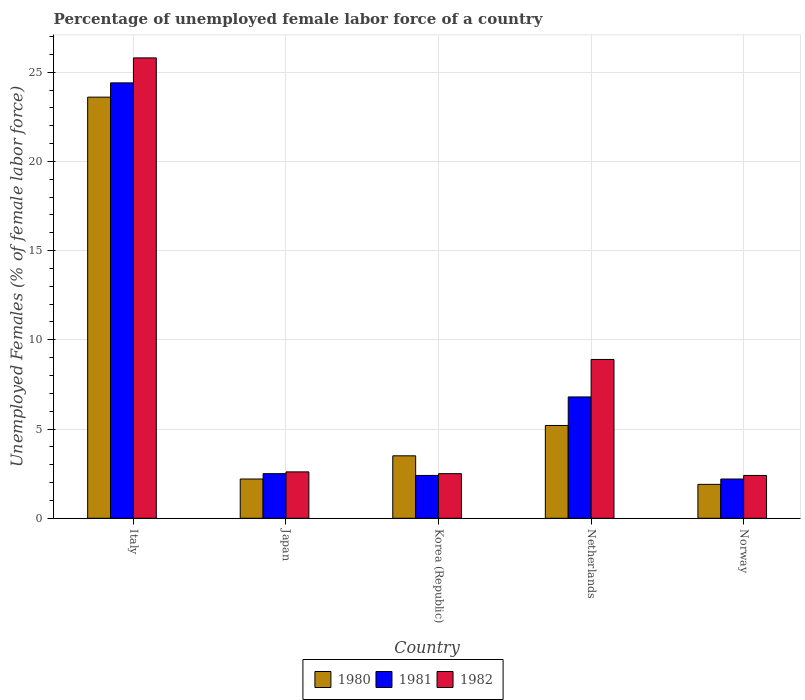Are the number of bars per tick equal to the number of legend labels?
Offer a terse response. Yes. What is the label of the 3rd group of bars from the left?
Keep it short and to the point. Korea (Republic). Across all countries, what is the maximum percentage of unemployed female labor force in 1981?
Keep it short and to the point. 24.4. Across all countries, what is the minimum percentage of unemployed female labor force in 1980?
Offer a terse response. 1.9. In which country was the percentage of unemployed female labor force in 1980 maximum?
Keep it short and to the point. Italy. In which country was the percentage of unemployed female labor force in 1980 minimum?
Ensure brevity in your answer.  Norway. What is the total percentage of unemployed female labor force in 1980 in the graph?
Make the answer very short. 36.4. What is the difference between the percentage of unemployed female labor force in 1981 in Netherlands and that in Norway?
Provide a short and direct response. 4.6. What is the difference between the percentage of unemployed female labor force in 1981 in Netherlands and the percentage of unemployed female labor force in 1980 in Norway?
Provide a short and direct response. 4.9. What is the average percentage of unemployed female labor force in 1980 per country?
Your answer should be very brief. 7.28. What is the difference between the percentage of unemployed female labor force of/in 1982 and percentage of unemployed female labor force of/in 1981 in Norway?
Your response must be concise. 0.2. What is the ratio of the percentage of unemployed female labor force in 1980 in Japan to that in Korea (Republic)?
Offer a very short reply. 0.63. What is the difference between the highest and the second highest percentage of unemployed female labor force in 1981?
Keep it short and to the point. 21.9. What is the difference between the highest and the lowest percentage of unemployed female labor force in 1980?
Offer a terse response. 21.7. What does the 2nd bar from the left in Japan represents?
Your answer should be very brief. 1981. What does the 2nd bar from the right in Italy represents?
Provide a short and direct response. 1981. How many bars are there?
Keep it short and to the point. 15. Are all the bars in the graph horizontal?
Your answer should be compact. No. Are the values on the major ticks of Y-axis written in scientific E-notation?
Your answer should be compact. No. Does the graph contain grids?
Give a very brief answer. Yes. How are the legend labels stacked?
Make the answer very short. Horizontal. What is the title of the graph?
Keep it short and to the point. Percentage of unemployed female labor force of a country. What is the label or title of the X-axis?
Your response must be concise. Country. What is the label or title of the Y-axis?
Provide a short and direct response. Unemployed Females (% of female labor force). What is the Unemployed Females (% of female labor force) in 1980 in Italy?
Provide a short and direct response. 23.6. What is the Unemployed Females (% of female labor force) in 1981 in Italy?
Your answer should be compact. 24.4. What is the Unemployed Females (% of female labor force) of 1982 in Italy?
Your answer should be compact. 25.8. What is the Unemployed Females (% of female labor force) in 1980 in Japan?
Provide a short and direct response. 2.2. What is the Unemployed Females (% of female labor force) of 1982 in Japan?
Give a very brief answer. 2.6. What is the Unemployed Females (% of female labor force) of 1980 in Korea (Republic)?
Make the answer very short. 3.5. What is the Unemployed Females (% of female labor force) in 1981 in Korea (Republic)?
Give a very brief answer. 2.4. What is the Unemployed Females (% of female labor force) of 1982 in Korea (Republic)?
Offer a very short reply. 2.5. What is the Unemployed Females (% of female labor force) of 1980 in Netherlands?
Ensure brevity in your answer.  5.2. What is the Unemployed Females (% of female labor force) in 1981 in Netherlands?
Give a very brief answer. 6.8. What is the Unemployed Females (% of female labor force) in 1982 in Netherlands?
Offer a very short reply. 8.9. What is the Unemployed Females (% of female labor force) of 1980 in Norway?
Provide a short and direct response. 1.9. What is the Unemployed Females (% of female labor force) in 1981 in Norway?
Offer a very short reply. 2.2. What is the Unemployed Females (% of female labor force) in 1982 in Norway?
Provide a succinct answer. 2.4. Across all countries, what is the maximum Unemployed Females (% of female labor force) in 1980?
Provide a succinct answer. 23.6. Across all countries, what is the maximum Unemployed Females (% of female labor force) of 1981?
Provide a short and direct response. 24.4. Across all countries, what is the maximum Unemployed Females (% of female labor force) in 1982?
Provide a short and direct response. 25.8. Across all countries, what is the minimum Unemployed Females (% of female labor force) of 1980?
Provide a short and direct response. 1.9. Across all countries, what is the minimum Unemployed Females (% of female labor force) of 1981?
Your answer should be very brief. 2.2. Across all countries, what is the minimum Unemployed Females (% of female labor force) in 1982?
Your response must be concise. 2.4. What is the total Unemployed Females (% of female labor force) of 1980 in the graph?
Your answer should be very brief. 36.4. What is the total Unemployed Females (% of female labor force) of 1981 in the graph?
Provide a succinct answer. 38.3. What is the total Unemployed Females (% of female labor force) in 1982 in the graph?
Your response must be concise. 42.2. What is the difference between the Unemployed Females (% of female labor force) of 1980 in Italy and that in Japan?
Your response must be concise. 21.4. What is the difference between the Unemployed Females (% of female labor force) of 1981 in Italy and that in Japan?
Keep it short and to the point. 21.9. What is the difference between the Unemployed Females (% of female labor force) in 1982 in Italy and that in Japan?
Provide a short and direct response. 23.2. What is the difference between the Unemployed Females (% of female labor force) in 1980 in Italy and that in Korea (Republic)?
Keep it short and to the point. 20.1. What is the difference between the Unemployed Females (% of female labor force) of 1981 in Italy and that in Korea (Republic)?
Give a very brief answer. 22. What is the difference between the Unemployed Females (% of female labor force) of 1982 in Italy and that in Korea (Republic)?
Offer a very short reply. 23.3. What is the difference between the Unemployed Females (% of female labor force) in 1980 in Italy and that in Norway?
Provide a succinct answer. 21.7. What is the difference between the Unemployed Females (% of female labor force) of 1982 in Italy and that in Norway?
Offer a very short reply. 23.4. What is the difference between the Unemployed Females (% of female labor force) in 1980 in Japan and that in Korea (Republic)?
Your answer should be very brief. -1.3. What is the difference between the Unemployed Females (% of female labor force) in 1981 in Japan and that in Korea (Republic)?
Provide a short and direct response. 0.1. What is the difference between the Unemployed Females (% of female labor force) of 1982 in Japan and that in Korea (Republic)?
Keep it short and to the point. 0.1. What is the difference between the Unemployed Females (% of female labor force) in 1980 in Japan and that in Netherlands?
Ensure brevity in your answer.  -3. What is the difference between the Unemployed Females (% of female labor force) in 1980 in Japan and that in Norway?
Give a very brief answer. 0.3. What is the difference between the Unemployed Females (% of female labor force) of 1981 in Japan and that in Norway?
Your answer should be compact. 0.3. What is the difference between the Unemployed Females (% of female labor force) of 1982 in Japan and that in Norway?
Offer a very short reply. 0.2. What is the difference between the Unemployed Females (% of female labor force) in 1981 in Korea (Republic) and that in Netherlands?
Provide a short and direct response. -4.4. What is the difference between the Unemployed Females (% of female labor force) of 1982 in Korea (Republic) and that in Netherlands?
Provide a succinct answer. -6.4. What is the difference between the Unemployed Females (% of female labor force) in 1982 in Korea (Republic) and that in Norway?
Your answer should be very brief. 0.1. What is the difference between the Unemployed Females (% of female labor force) of 1980 in Netherlands and that in Norway?
Offer a terse response. 3.3. What is the difference between the Unemployed Females (% of female labor force) of 1981 in Netherlands and that in Norway?
Offer a terse response. 4.6. What is the difference between the Unemployed Females (% of female labor force) of 1980 in Italy and the Unemployed Females (% of female labor force) of 1981 in Japan?
Ensure brevity in your answer.  21.1. What is the difference between the Unemployed Females (% of female labor force) of 1980 in Italy and the Unemployed Females (% of female labor force) of 1982 in Japan?
Ensure brevity in your answer.  21. What is the difference between the Unemployed Females (% of female labor force) of 1981 in Italy and the Unemployed Females (% of female labor force) of 1982 in Japan?
Provide a short and direct response. 21.8. What is the difference between the Unemployed Females (% of female labor force) in 1980 in Italy and the Unemployed Females (% of female labor force) in 1981 in Korea (Republic)?
Your response must be concise. 21.2. What is the difference between the Unemployed Females (% of female labor force) in 1980 in Italy and the Unemployed Females (% of female labor force) in 1982 in Korea (Republic)?
Your answer should be very brief. 21.1. What is the difference between the Unemployed Females (% of female labor force) in 1981 in Italy and the Unemployed Females (% of female labor force) in 1982 in Korea (Republic)?
Offer a terse response. 21.9. What is the difference between the Unemployed Females (% of female labor force) of 1980 in Italy and the Unemployed Females (% of female labor force) of 1981 in Netherlands?
Your response must be concise. 16.8. What is the difference between the Unemployed Females (% of female labor force) in 1980 in Italy and the Unemployed Females (% of female labor force) in 1982 in Netherlands?
Offer a very short reply. 14.7. What is the difference between the Unemployed Females (% of female labor force) in 1980 in Italy and the Unemployed Females (% of female labor force) in 1981 in Norway?
Your answer should be very brief. 21.4. What is the difference between the Unemployed Females (% of female labor force) in 1980 in Italy and the Unemployed Females (% of female labor force) in 1982 in Norway?
Provide a succinct answer. 21.2. What is the difference between the Unemployed Females (% of female labor force) in 1981 in Italy and the Unemployed Females (% of female labor force) in 1982 in Norway?
Provide a short and direct response. 22. What is the difference between the Unemployed Females (% of female labor force) in 1980 in Japan and the Unemployed Females (% of female labor force) in 1982 in Korea (Republic)?
Provide a succinct answer. -0.3. What is the difference between the Unemployed Females (% of female labor force) of 1981 in Japan and the Unemployed Females (% of female labor force) of 1982 in Korea (Republic)?
Your answer should be compact. 0. What is the difference between the Unemployed Females (% of female labor force) in 1980 in Japan and the Unemployed Females (% of female labor force) in 1982 in Norway?
Keep it short and to the point. -0.2. What is the difference between the Unemployed Females (% of female labor force) of 1981 in Japan and the Unemployed Females (% of female labor force) of 1982 in Norway?
Ensure brevity in your answer.  0.1. What is the difference between the Unemployed Females (% of female labor force) of 1981 in Korea (Republic) and the Unemployed Females (% of female labor force) of 1982 in Norway?
Your response must be concise. 0. What is the difference between the Unemployed Females (% of female labor force) of 1980 in Netherlands and the Unemployed Females (% of female labor force) of 1981 in Norway?
Offer a very short reply. 3. What is the average Unemployed Females (% of female labor force) of 1980 per country?
Your answer should be very brief. 7.28. What is the average Unemployed Females (% of female labor force) of 1981 per country?
Provide a short and direct response. 7.66. What is the average Unemployed Females (% of female labor force) in 1982 per country?
Your answer should be compact. 8.44. What is the difference between the Unemployed Females (% of female labor force) of 1980 and Unemployed Females (% of female labor force) of 1982 in Italy?
Your answer should be very brief. -2.2. What is the difference between the Unemployed Females (% of female labor force) in 1981 and Unemployed Females (% of female labor force) in 1982 in Italy?
Your response must be concise. -1.4. What is the difference between the Unemployed Females (% of female labor force) in 1980 and Unemployed Females (% of female labor force) in 1982 in Japan?
Provide a short and direct response. -0.4. What is the difference between the Unemployed Females (% of female labor force) of 1981 and Unemployed Females (% of female labor force) of 1982 in Japan?
Keep it short and to the point. -0.1. What is the difference between the Unemployed Females (% of female labor force) of 1980 and Unemployed Females (% of female labor force) of 1981 in Korea (Republic)?
Offer a terse response. 1.1. What is the difference between the Unemployed Females (% of female labor force) in 1980 and Unemployed Females (% of female labor force) in 1982 in Korea (Republic)?
Ensure brevity in your answer.  1. What is the difference between the Unemployed Females (% of female labor force) in 1981 and Unemployed Females (% of female labor force) in 1982 in Korea (Republic)?
Your response must be concise. -0.1. What is the difference between the Unemployed Females (% of female labor force) of 1980 and Unemployed Females (% of female labor force) of 1981 in Netherlands?
Keep it short and to the point. -1.6. What is the difference between the Unemployed Females (% of female labor force) of 1981 and Unemployed Females (% of female labor force) of 1982 in Netherlands?
Your answer should be very brief. -2.1. What is the difference between the Unemployed Females (% of female labor force) of 1980 and Unemployed Females (% of female labor force) of 1981 in Norway?
Your answer should be very brief. -0.3. What is the difference between the Unemployed Females (% of female labor force) of 1981 and Unemployed Females (% of female labor force) of 1982 in Norway?
Offer a very short reply. -0.2. What is the ratio of the Unemployed Females (% of female labor force) in 1980 in Italy to that in Japan?
Your response must be concise. 10.73. What is the ratio of the Unemployed Females (% of female labor force) in 1981 in Italy to that in Japan?
Provide a short and direct response. 9.76. What is the ratio of the Unemployed Females (% of female labor force) of 1982 in Italy to that in Japan?
Give a very brief answer. 9.92. What is the ratio of the Unemployed Females (% of female labor force) in 1980 in Italy to that in Korea (Republic)?
Your response must be concise. 6.74. What is the ratio of the Unemployed Females (% of female labor force) of 1981 in Italy to that in Korea (Republic)?
Keep it short and to the point. 10.17. What is the ratio of the Unemployed Females (% of female labor force) of 1982 in Italy to that in Korea (Republic)?
Offer a terse response. 10.32. What is the ratio of the Unemployed Females (% of female labor force) of 1980 in Italy to that in Netherlands?
Your answer should be compact. 4.54. What is the ratio of the Unemployed Females (% of female labor force) in 1981 in Italy to that in Netherlands?
Your answer should be compact. 3.59. What is the ratio of the Unemployed Females (% of female labor force) of 1982 in Italy to that in Netherlands?
Provide a short and direct response. 2.9. What is the ratio of the Unemployed Females (% of female labor force) in 1980 in Italy to that in Norway?
Provide a succinct answer. 12.42. What is the ratio of the Unemployed Females (% of female labor force) of 1981 in Italy to that in Norway?
Keep it short and to the point. 11.09. What is the ratio of the Unemployed Females (% of female labor force) in 1982 in Italy to that in Norway?
Make the answer very short. 10.75. What is the ratio of the Unemployed Females (% of female labor force) of 1980 in Japan to that in Korea (Republic)?
Your answer should be very brief. 0.63. What is the ratio of the Unemployed Females (% of female labor force) in 1981 in Japan to that in Korea (Republic)?
Ensure brevity in your answer.  1.04. What is the ratio of the Unemployed Females (% of female labor force) in 1980 in Japan to that in Netherlands?
Your answer should be compact. 0.42. What is the ratio of the Unemployed Females (% of female labor force) in 1981 in Japan to that in Netherlands?
Make the answer very short. 0.37. What is the ratio of the Unemployed Females (% of female labor force) of 1982 in Japan to that in Netherlands?
Ensure brevity in your answer.  0.29. What is the ratio of the Unemployed Females (% of female labor force) in 1980 in Japan to that in Norway?
Offer a very short reply. 1.16. What is the ratio of the Unemployed Females (% of female labor force) in 1981 in Japan to that in Norway?
Offer a very short reply. 1.14. What is the ratio of the Unemployed Females (% of female labor force) in 1982 in Japan to that in Norway?
Your response must be concise. 1.08. What is the ratio of the Unemployed Females (% of female labor force) in 1980 in Korea (Republic) to that in Netherlands?
Offer a terse response. 0.67. What is the ratio of the Unemployed Females (% of female labor force) in 1981 in Korea (Republic) to that in Netherlands?
Ensure brevity in your answer.  0.35. What is the ratio of the Unemployed Females (% of female labor force) of 1982 in Korea (Republic) to that in Netherlands?
Your response must be concise. 0.28. What is the ratio of the Unemployed Females (% of female labor force) in 1980 in Korea (Republic) to that in Norway?
Keep it short and to the point. 1.84. What is the ratio of the Unemployed Females (% of female labor force) in 1981 in Korea (Republic) to that in Norway?
Your response must be concise. 1.09. What is the ratio of the Unemployed Females (% of female labor force) in 1982 in Korea (Republic) to that in Norway?
Make the answer very short. 1.04. What is the ratio of the Unemployed Females (% of female labor force) of 1980 in Netherlands to that in Norway?
Keep it short and to the point. 2.74. What is the ratio of the Unemployed Females (% of female labor force) of 1981 in Netherlands to that in Norway?
Offer a very short reply. 3.09. What is the ratio of the Unemployed Females (% of female labor force) of 1982 in Netherlands to that in Norway?
Offer a very short reply. 3.71. What is the difference between the highest and the second highest Unemployed Females (% of female labor force) in 1980?
Provide a short and direct response. 18.4. What is the difference between the highest and the lowest Unemployed Females (% of female labor force) in 1980?
Offer a terse response. 21.7. What is the difference between the highest and the lowest Unemployed Females (% of female labor force) of 1982?
Your answer should be very brief. 23.4. 